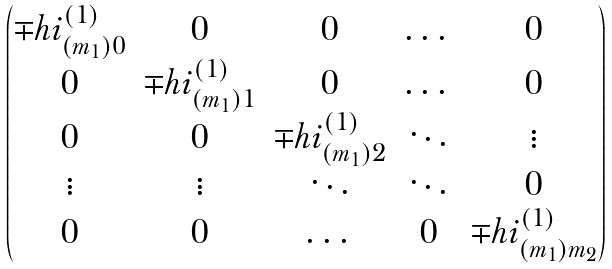<formula> <loc_0><loc_0><loc_500><loc_500>\begin{pmatrix} \mp h i ^ { ( 1 ) } _ { ( m _ { 1 } ) 0 } & 0 & 0 & \dots & 0 \\ 0 & \mp h i ^ { ( 1 ) } _ { ( m _ { 1 } ) 1 } & 0 & \dots & 0 \\ 0 & 0 & \mp h i ^ { ( 1 ) } _ { ( m _ { 1 } ) 2 } & \ddots & \vdots \\ \vdots & \vdots & \ddots & \ddots & 0 \\ 0 & 0 & \dots & 0 & \mp h i ^ { ( 1 ) } _ { ( m _ { 1 } ) m _ { 2 } } \end{pmatrix}</formula> 